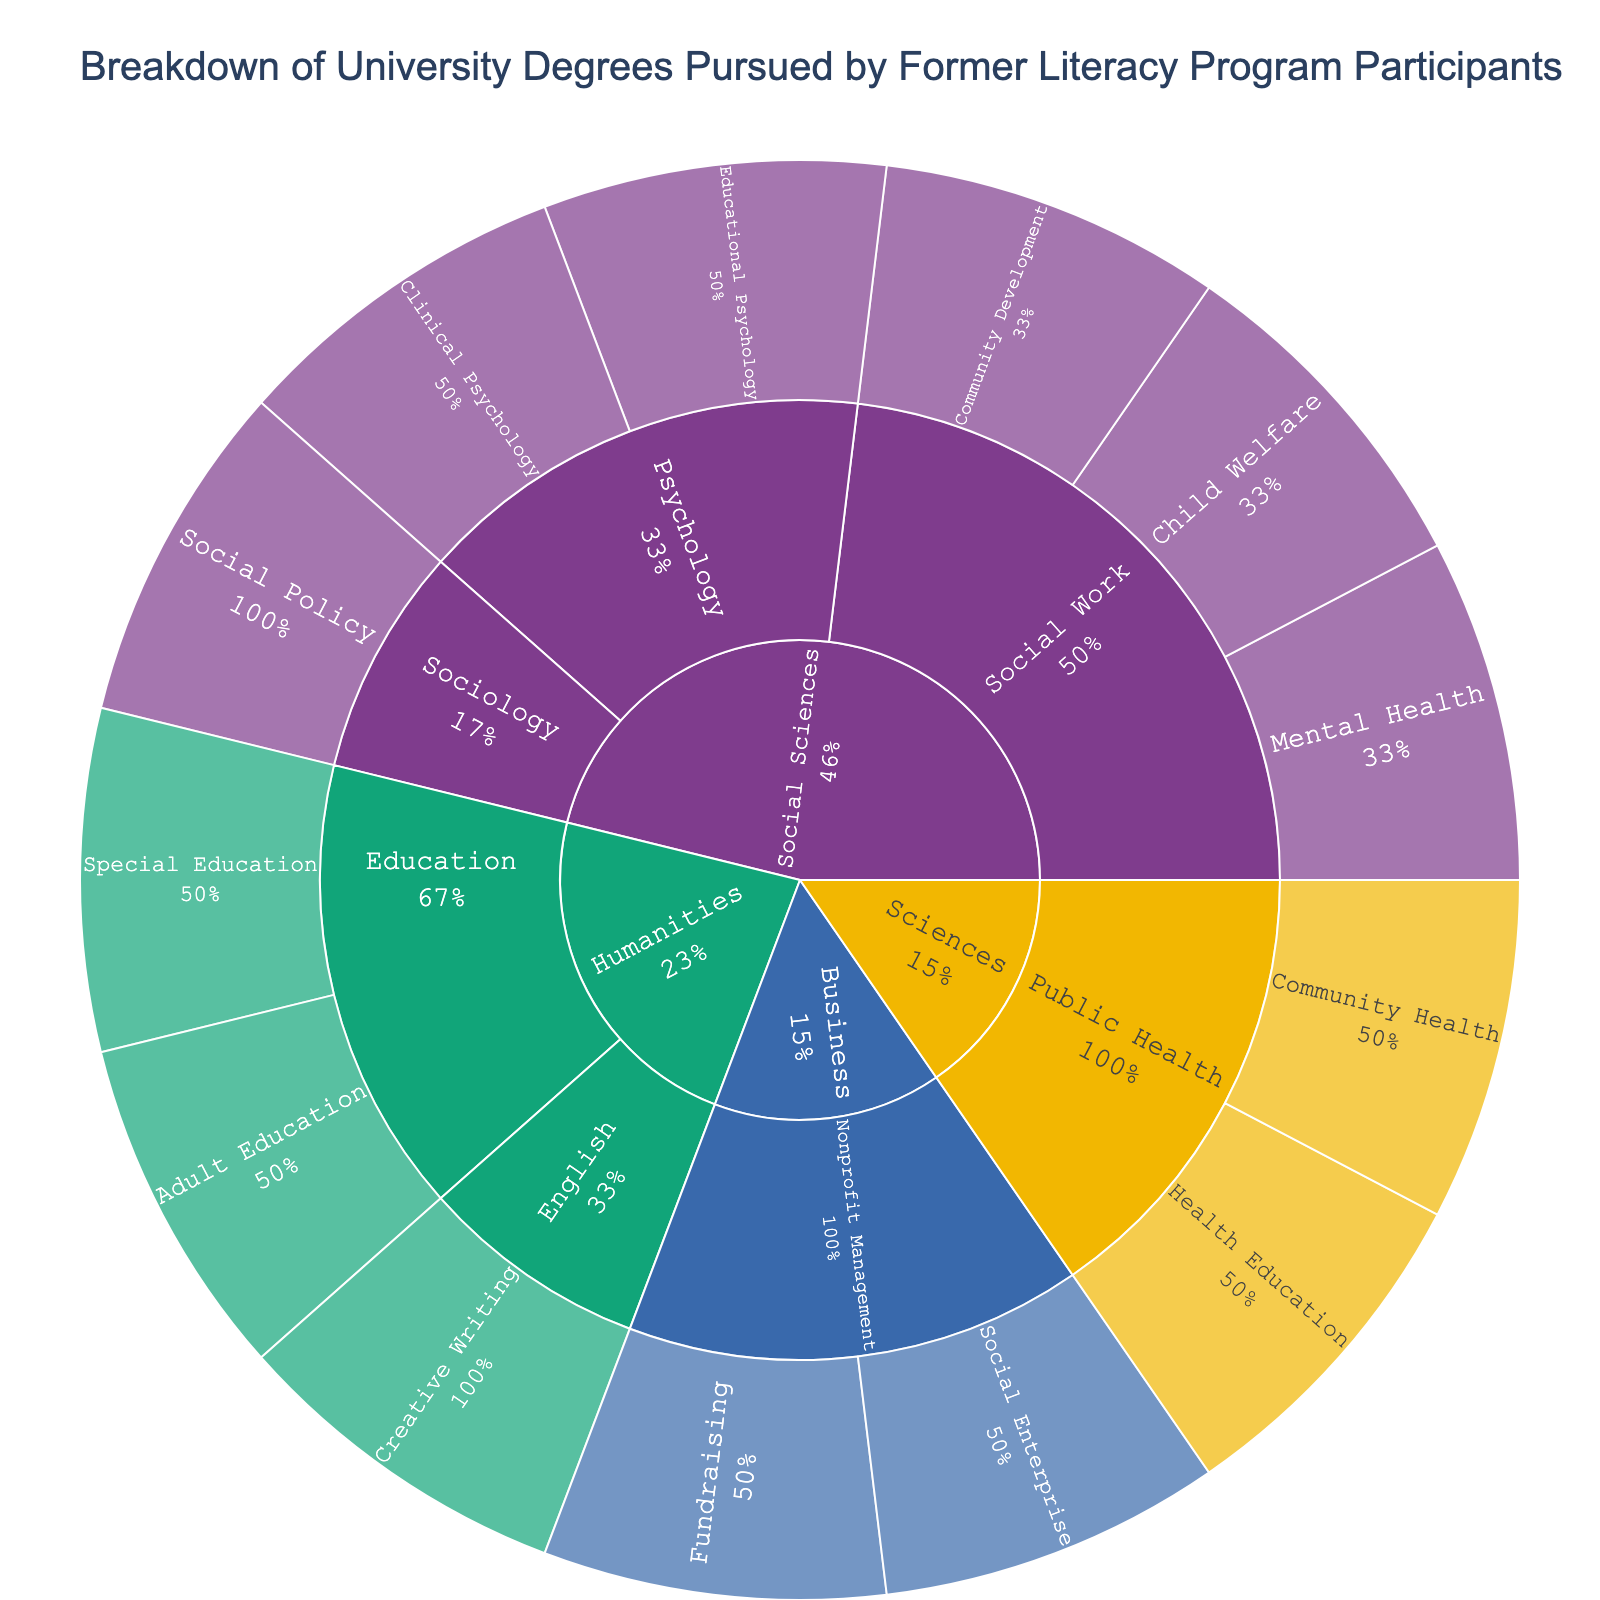What is the title of the figure? The title is usually displayed at the top of the figure. It describes what the figure is about. In this case, the title indicates the content and the context of the data shown.
Answer: Breakdown of University Degrees Pursued by Former Literacy Program Participants Which degree field contains the specialization in 'Community Development'? To determine this, observe the path from the 'Community Development' specialization through its parent nodes.
Answer: Social Work Which degree has the most specializations overall? To find the degree with the most specializations, count the number of specializations under each degree. The degree with the highest count is the answer.
Answer: Social Sciences How many specializations are there under the 'Humanities' degree? To answer, count the number of specializations listed under each of the fields within the Humanities degree.
Answer: 3 What percent of total participants are pursuing 'Social Work' specializations? The 'Social Work' specializations are the child nodes under 'Social Work'. Sum the percentages mentioned next to these specializations to get the total percentage.
Answer: 25% (assuming 'Child Welfare', 'Community Development', and 'Mental Health' are evenly split) How does the percentage of participants in 'Sociology' compare to 'Psychology' within the 'Social Sciences' degree? Look at the percentage labels under 'Sociology' and 'Psychology' to compare them.
Answer: Sociology has fewer percentage than Psychology Which field is more popular: 'Nonprofit Management' or 'Public Health'? Compare the size and/or percentage of participants shown for 'Nonprofit Management' and 'Public Health' by examining their slices in the sunburst plot.
Answer: Public Health Within the 'Education' field, which specialization is more common: 'Adult Education' or 'Special Education'? Look at the percentages given for 'Adult Education' and 'Special Education' specializations under the 'Education' field to determine which is more common.
Answer: Special Education Which specialization under 'Public Health' has a higher percentage of participants? Compare the slices or percentages of the specializations under 'Public Health'.
Answer: Community Health What percentage of the 'Business' degree participants are engaged in 'Fundraising'? Refer to the 'Business' degree section and look at the 'Fundraising' specialization to get its percentage.
Answer: 50% (assuming 'Social Enterprise' and 'Fundraising' are evenly split) 